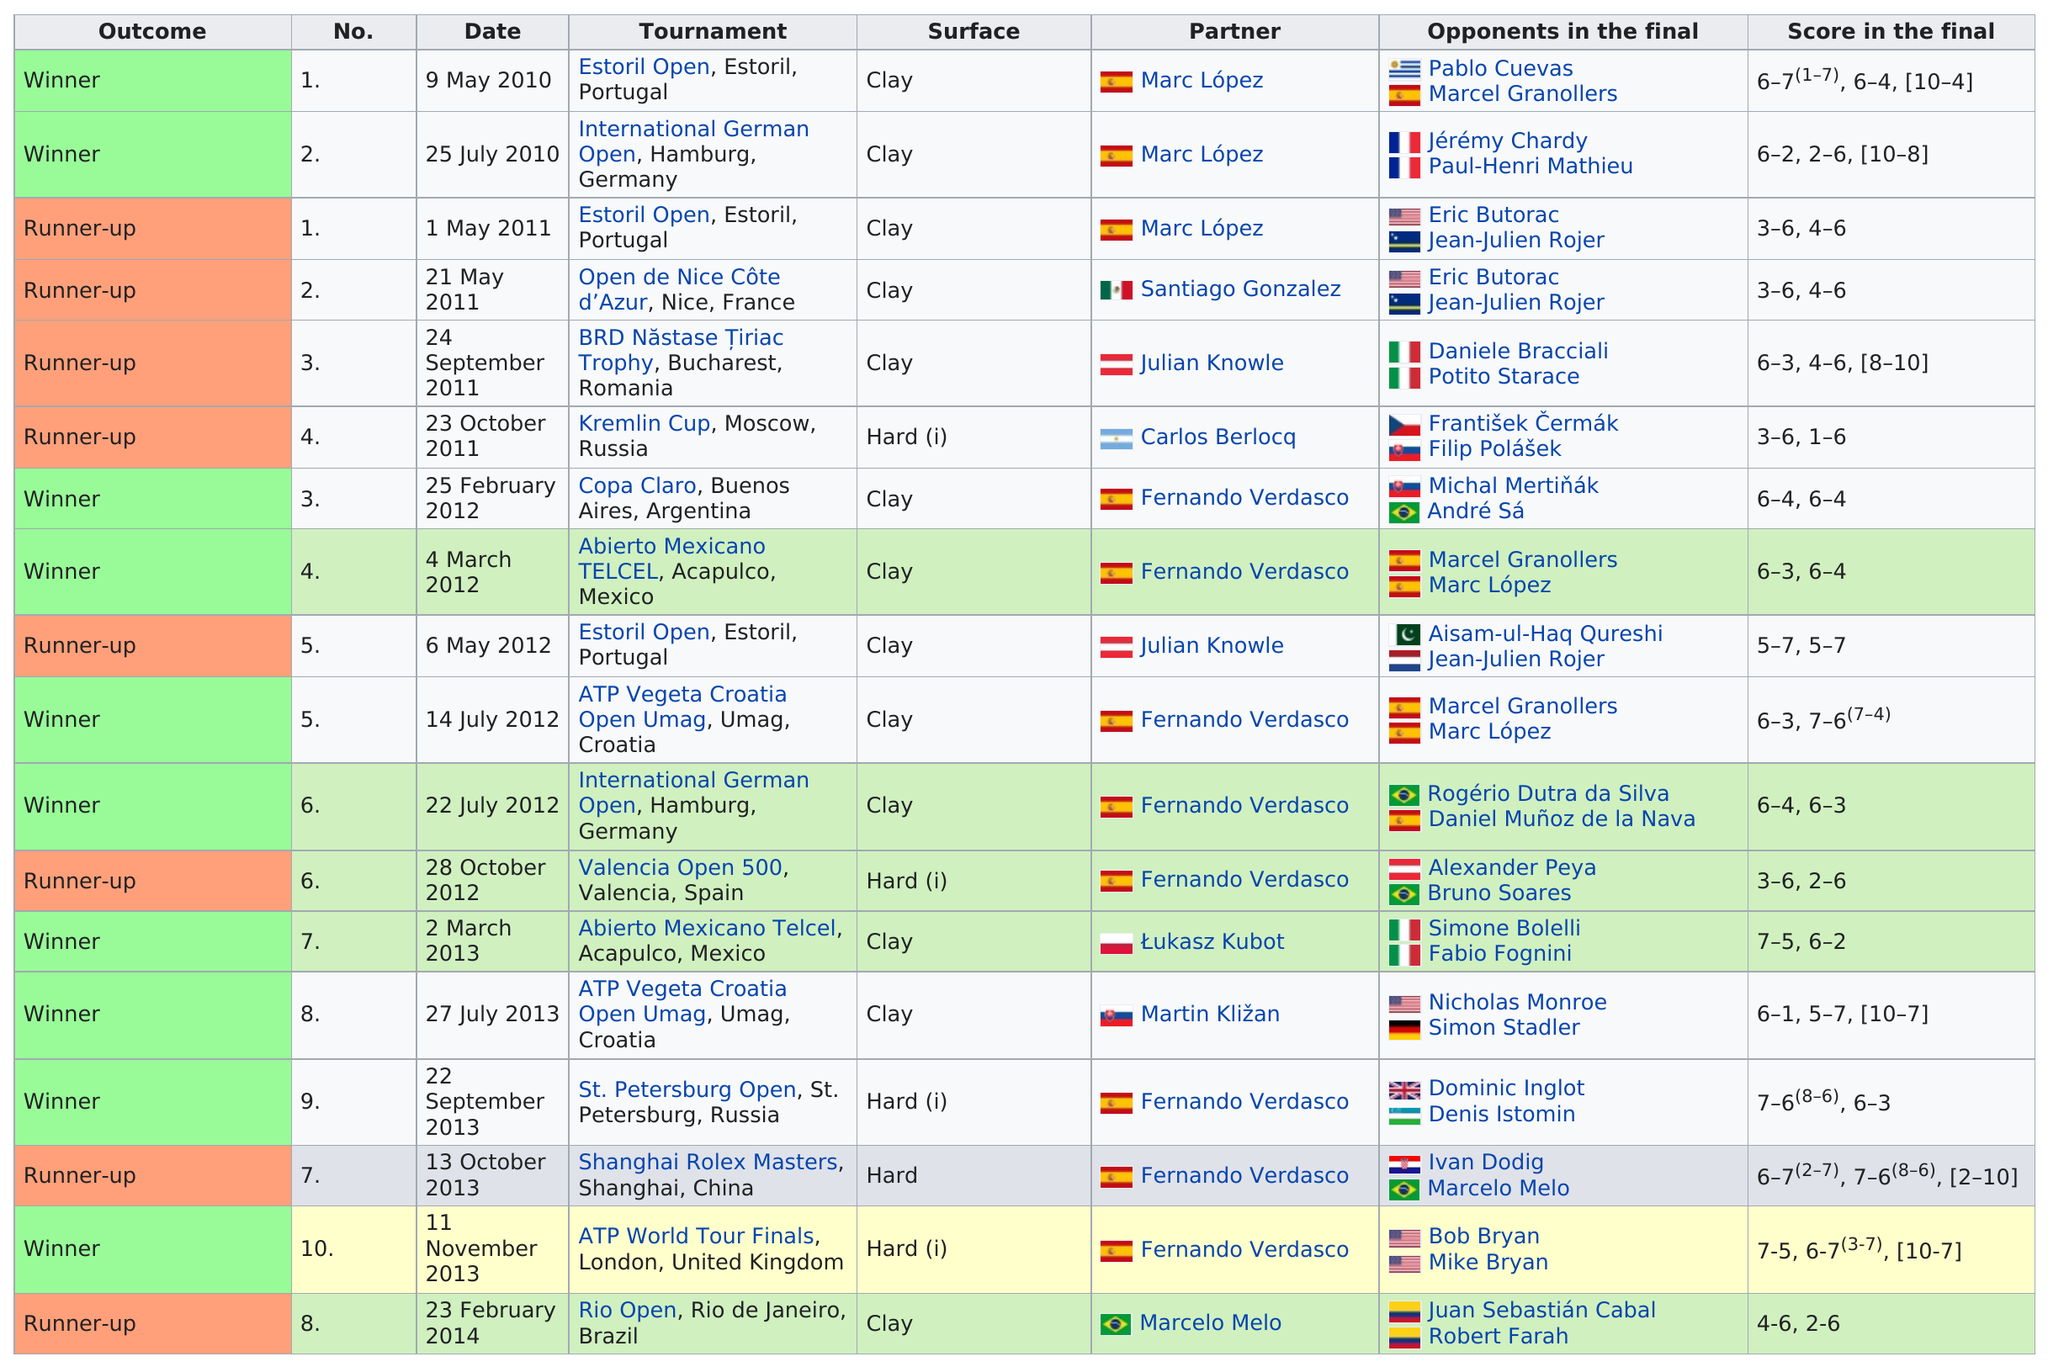Outline some significant characteristics in this image. The maximum number of runner-ups that will be listed is 8. The ATP World Tour Finals tournament is the one with the largest number of participants. There are 10 winners. The number of times a hard surface was used was 5. The Copa Claro, held in Buenos Aires, Argentina, was the tournament played after the Kremlin Cup. 